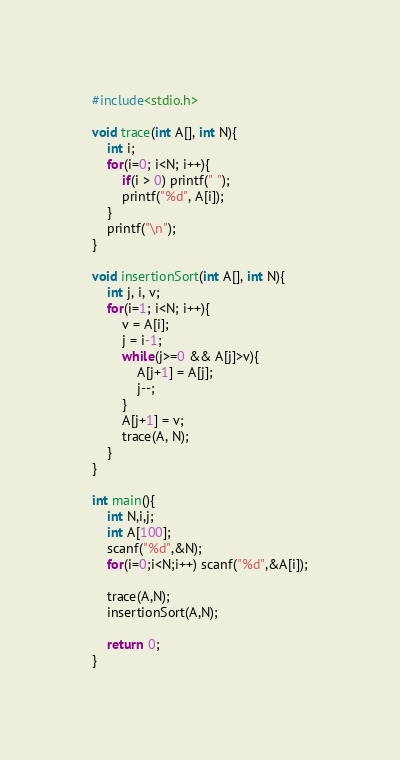Convert code to text. <code><loc_0><loc_0><loc_500><loc_500><_C_>#include<stdio.h>

void trace(int A[], int N){
	int i;
	for(i=0; i<N; i++){
		if(i > 0) printf(" ");
		printf("%d", A[i]);
	}
	printf("\n");
}

void insertionSort(int A[], int N){
	int j, i, v;
	for(i=1; i<N; i++){
		v = A[i];
		j = i-1;
		while(j>=0 && A[j]>v){
			A[j+1] = A[j];
			j--;
		}
		A[j+1] = v;
		trace(A, N);
	}
}

int main(){
	int N,i,j;
	int A[100];
	scanf("%d",&N);
	for(i=0;i<N;i++) scanf("%d",&A[i]);
	
	trace(A,N);
	insertionSort(A,N);
	
	return 0;
}</code> 